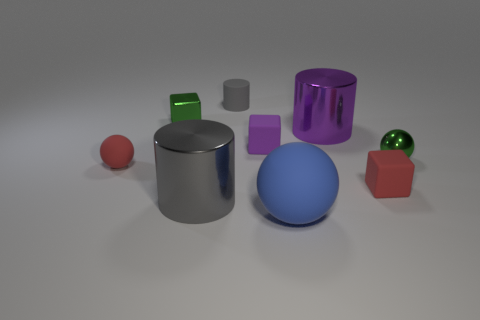Subtract all large matte spheres. How many spheres are left? 2 Subtract 1 cubes. How many cubes are left? 2 Subtract all purple blocks. How many blocks are left? 2 Subtract 1 purple cubes. How many objects are left? 8 Subtract all cylinders. How many objects are left? 6 Subtract all purple spheres. Subtract all brown cylinders. How many spheres are left? 3 Subtract all purple cubes. How many gray cylinders are left? 2 Subtract all big green cylinders. Subtract all tiny purple objects. How many objects are left? 8 Add 5 blocks. How many blocks are left? 8 Add 1 large matte blocks. How many large matte blocks exist? 1 